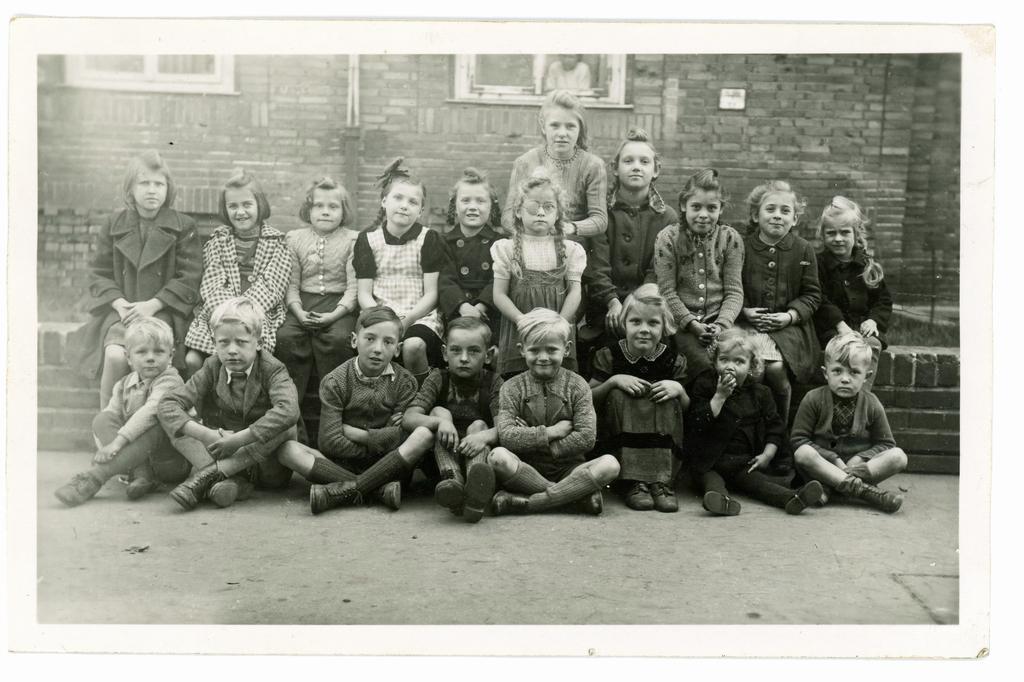Describe this image in one or two sentences. In the picture I can see a group of children. I can see few of them sitting on the wall and few of them sitting on the floor. In the background, I can see the brick wall and glass windows. 